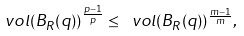<formula> <loc_0><loc_0><loc_500><loc_500>\ v o l ( B _ { R } ( q ) ) ^ { \frac { p - 1 } { p } } \leq \ v o l ( B _ { R } ( q ) ) ^ { \frac { m - 1 } { m } } ,</formula> 